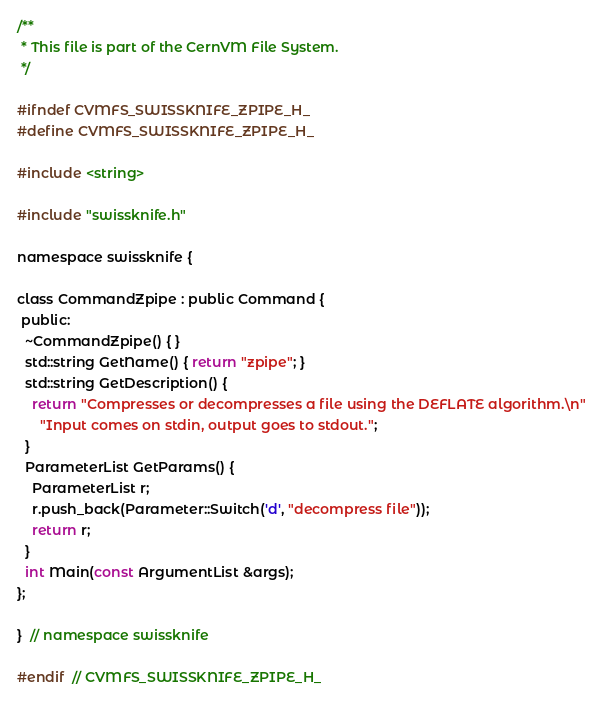<code> <loc_0><loc_0><loc_500><loc_500><_C_>/**
 * This file is part of the CernVM File System.
 */

#ifndef CVMFS_SWISSKNIFE_ZPIPE_H_
#define CVMFS_SWISSKNIFE_ZPIPE_H_

#include <string>

#include "swissknife.h"

namespace swissknife {

class CommandZpipe : public Command {
 public:
  ~CommandZpipe() { }
  std::string GetName() { return "zpipe"; }
  std::string GetDescription() {
    return "Compresses or decompresses a file using the DEFLATE algorithm.\n"
      "Input comes on stdin, output goes to stdout.";
  }
  ParameterList GetParams() {
    ParameterList r;
    r.push_back(Parameter::Switch('d', "decompress file"));
    return r;
  }
  int Main(const ArgumentList &args);
};

}  // namespace swissknife

#endif  // CVMFS_SWISSKNIFE_ZPIPE_H_
</code> 